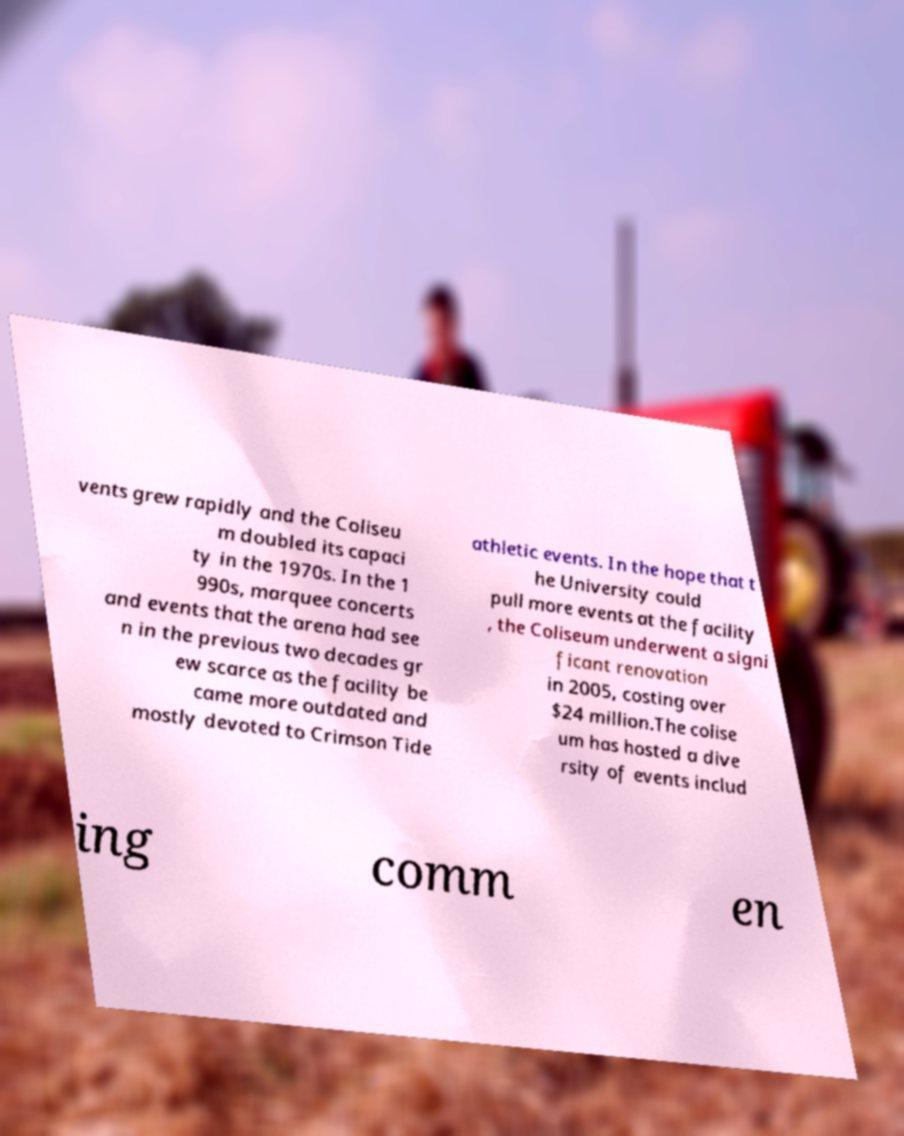Please identify and transcribe the text found in this image. vents grew rapidly and the Coliseu m doubled its capaci ty in the 1970s. In the 1 990s, marquee concerts and events that the arena had see n in the previous two decades gr ew scarce as the facility be came more outdated and mostly devoted to Crimson Tide athletic events. In the hope that t he University could pull more events at the facility , the Coliseum underwent a signi ficant renovation in 2005, costing over $24 million.The colise um has hosted a dive rsity of events includ ing comm en 